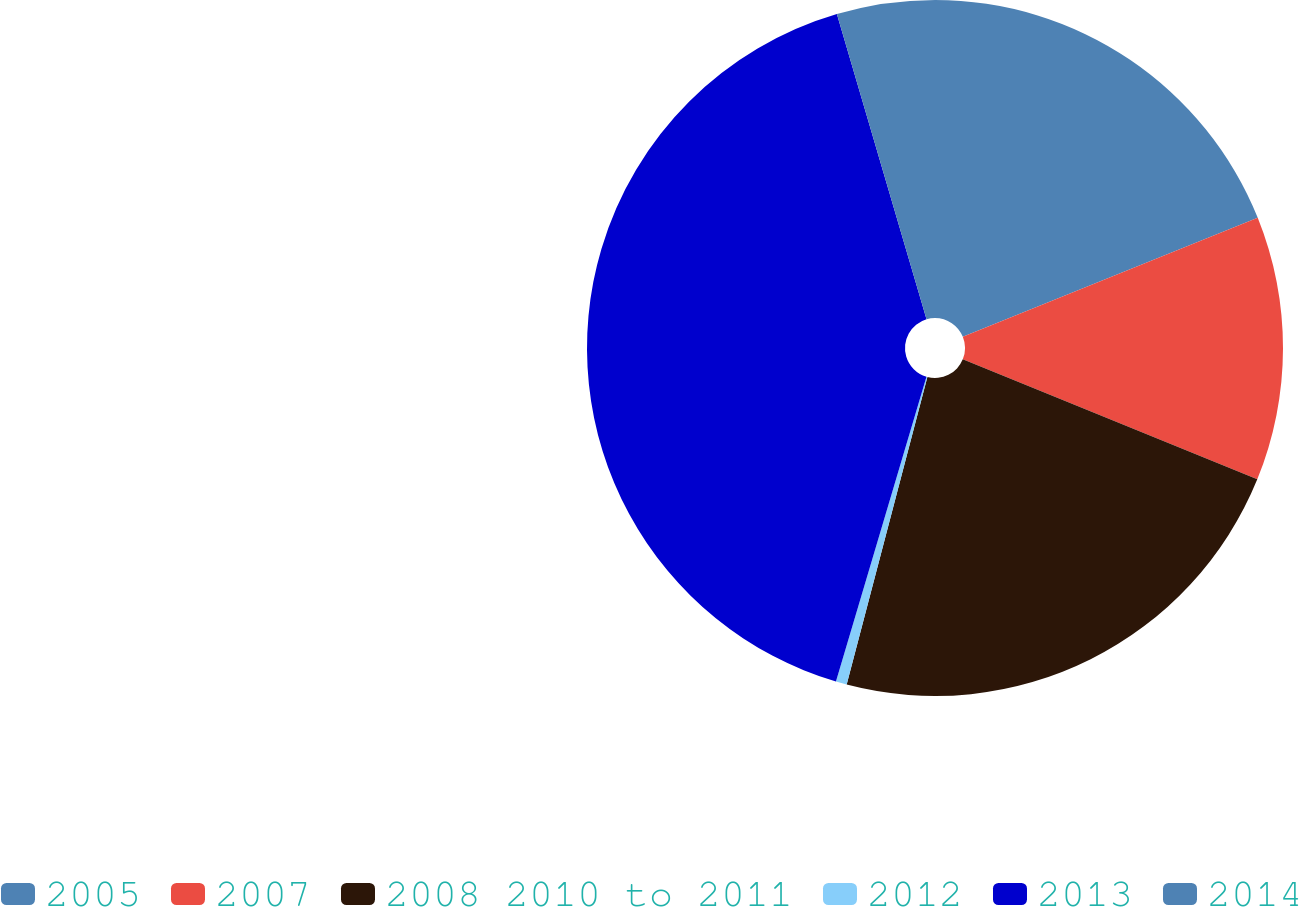<chart> <loc_0><loc_0><loc_500><loc_500><pie_chart><fcel>2005<fcel>2007<fcel>2008 2010 to 2011<fcel>2012<fcel>2013<fcel>2014<nl><fcel>18.9%<fcel>12.26%<fcel>22.93%<fcel>0.51%<fcel>40.86%<fcel>4.55%<nl></chart> 